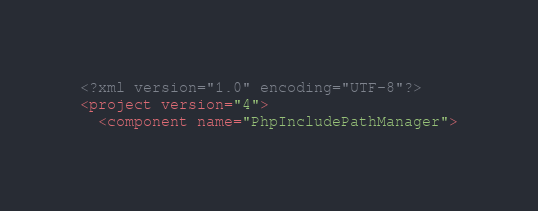Convert code to text. <code><loc_0><loc_0><loc_500><loc_500><_XML_><?xml version="1.0" encoding="UTF-8"?>
<project version="4">
  <component name="PhpIncludePathManager"></code> 